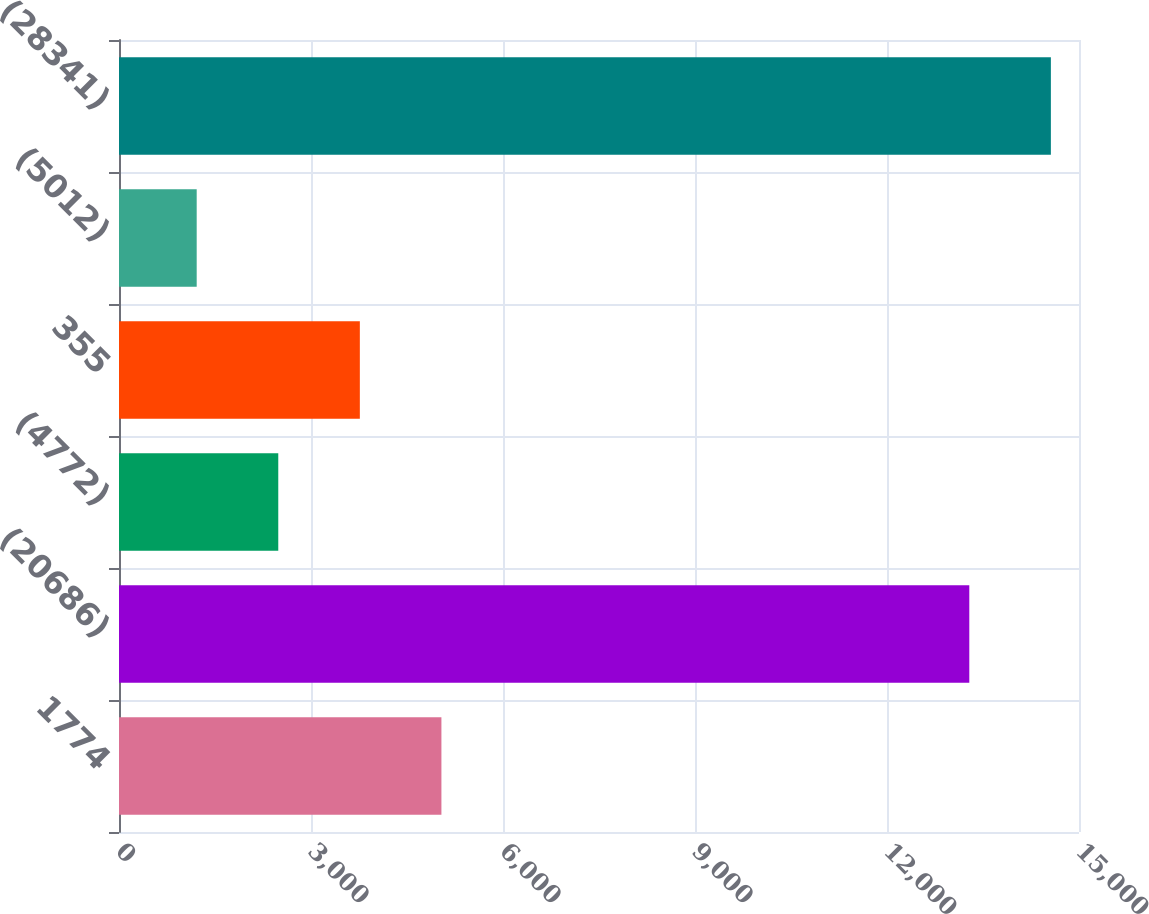Convert chart to OTSL. <chart><loc_0><loc_0><loc_500><loc_500><bar_chart><fcel>1774<fcel>(20686)<fcel>(4772)<fcel>355<fcel>(5012)<fcel>(28341)<nl><fcel>5037.8<fcel>13286<fcel>2488.6<fcel>3763.2<fcel>1214<fcel>14560.6<nl></chart> 